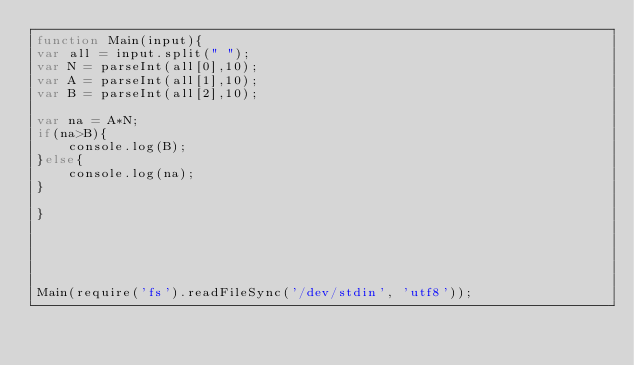<code> <loc_0><loc_0><loc_500><loc_500><_JavaScript_>function Main(input){
var all = input.split(" ");
var N = parseInt(all[0],10);
var A = parseInt(all[1],10);
var B = parseInt(all[2],10);

var na = A*N;
if(na>B){
    console.log(B);
}else{
    console.log(na);
}

}





Main(require('fs').readFileSync('/dev/stdin', 'utf8'));</code> 